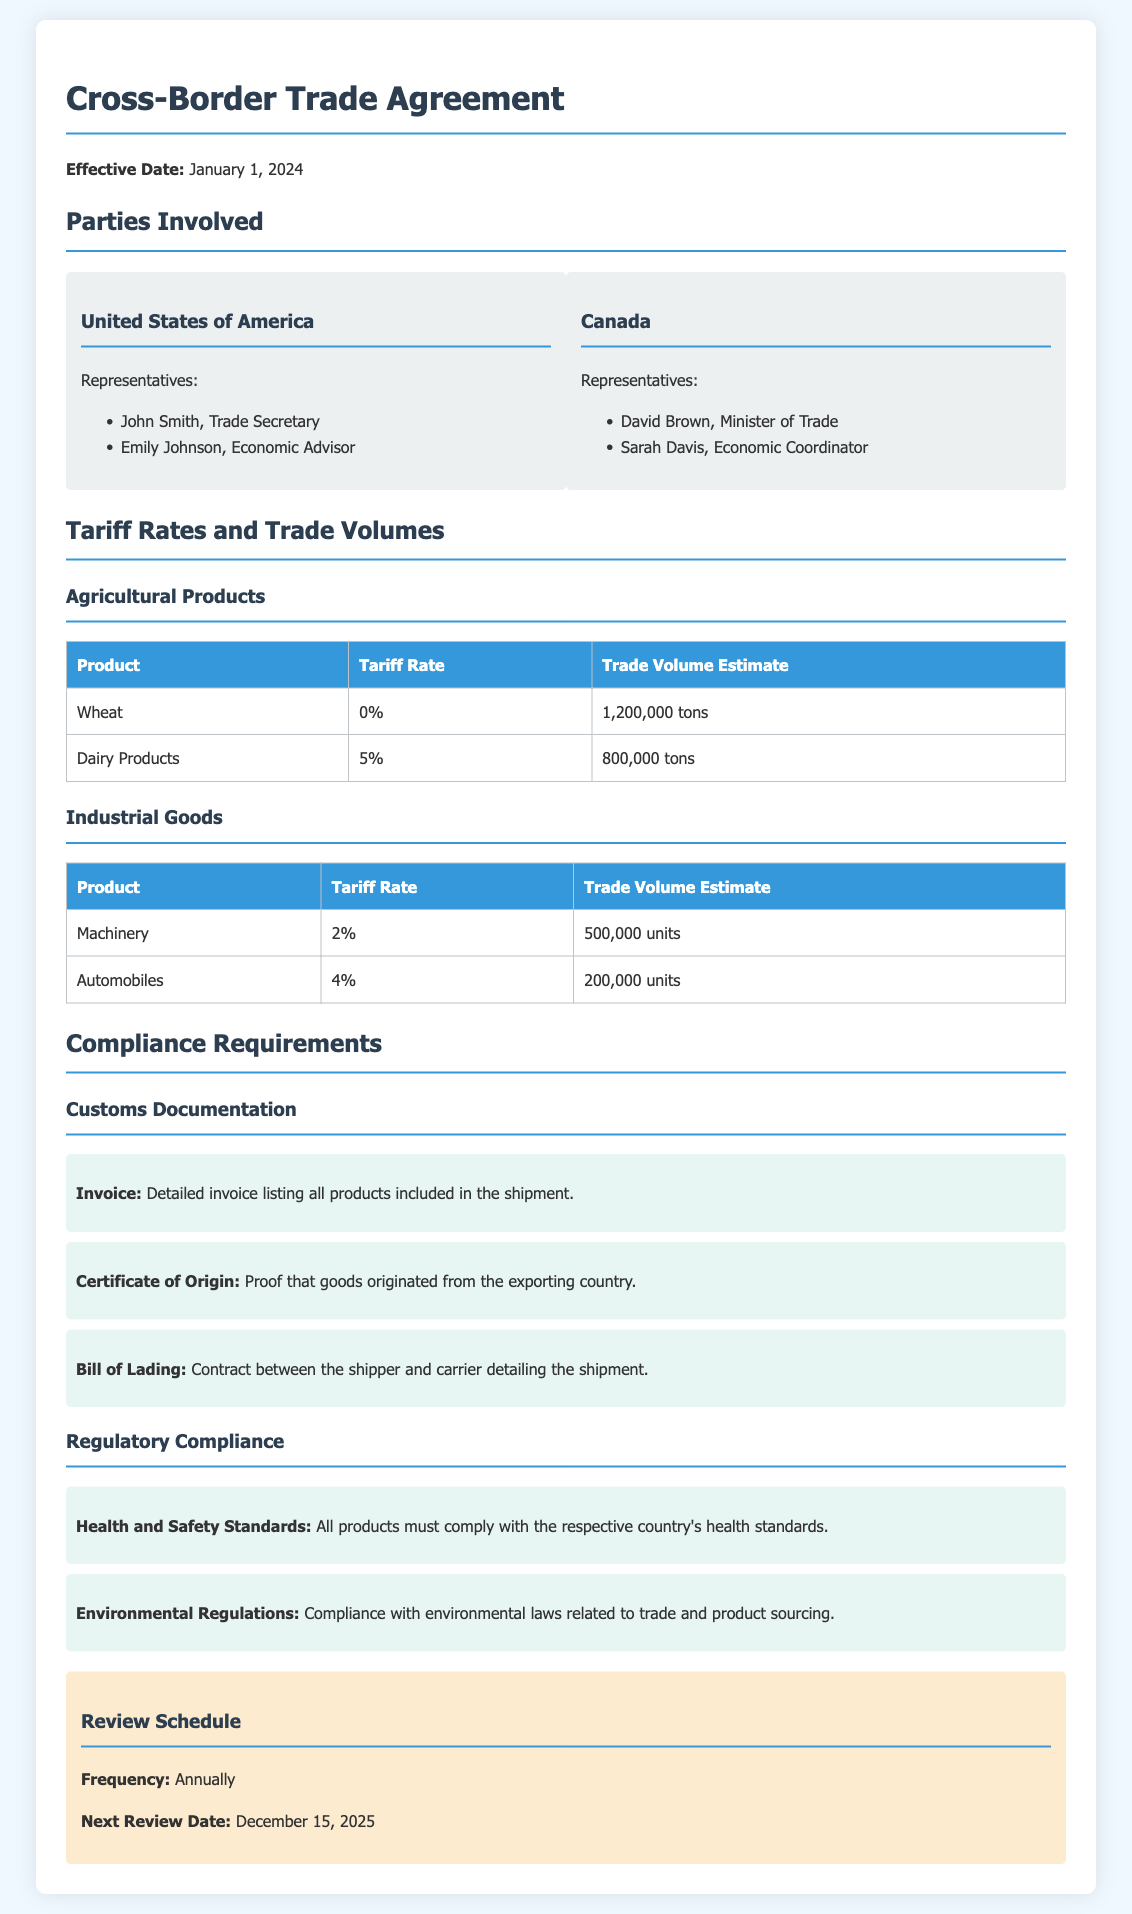What is the effective date of the agreement? The effective date is explicitly mentioned in the document, which is January 1, 2024.
Answer: January 1, 2024 Who represents Canada in the trade agreement? David Brown and Sarah Davis are listed as representatives of Canada in the document.
Answer: David Brown, Sarah Davis What is the tariff rate for Dairy Products? The tariff rate for Dairy Products is specifically stated in the table section of the document.
Answer: 5% What is the estimated trade volume for Wheat? The estimated trade volume for Wheat is clearly indicated in the document's table under Agricultural Products.
Answer: 1,200,000 tons What document is required as proof of origin? The document that serves as proof of origin is stated under the compliance requirements.
Answer: Certificate of Origin How often will the review of the agreement occur? The frequency of the review is mentioned, indicating how often it takes place.
Answer: Annually What is the next review date scheduled for the agreement? The next review date is explicitly mentioned in the review schedule section of the document.
Answer: December 15, 2025 What must products comply with regarding health standards? The compliance requirement related to health standards is specified in the regulatory section of the document.
Answer: Health and Safety Standards What is the tariff rate for Machinery? The tariff rate for Machinery is clearly listed in the document's table for Industrial Goods.
Answer: 2% 